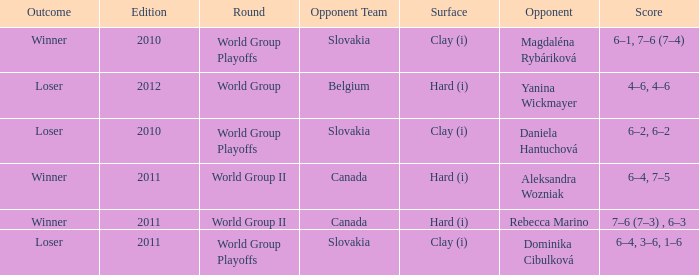How many outcomes were there when the opponent was Aleksandra Wozniak? 1.0. 